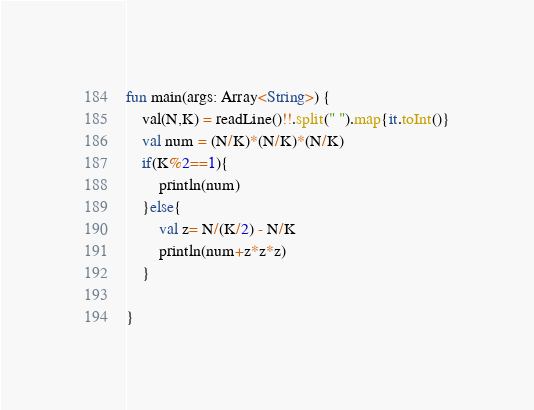<code> <loc_0><loc_0><loc_500><loc_500><_Kotlin_>fun main(args: Array<String>) {
    val(N,K) = readLine()!!.split(" ").map{it.toInt()}
    val num = (N/K)*(N/K)*(N/K)
    if(K%2==1){
        println(num)
    }else{
        val z= N/(K/2) - N/K
        println(num+z*z*z)
    }

}</code> 